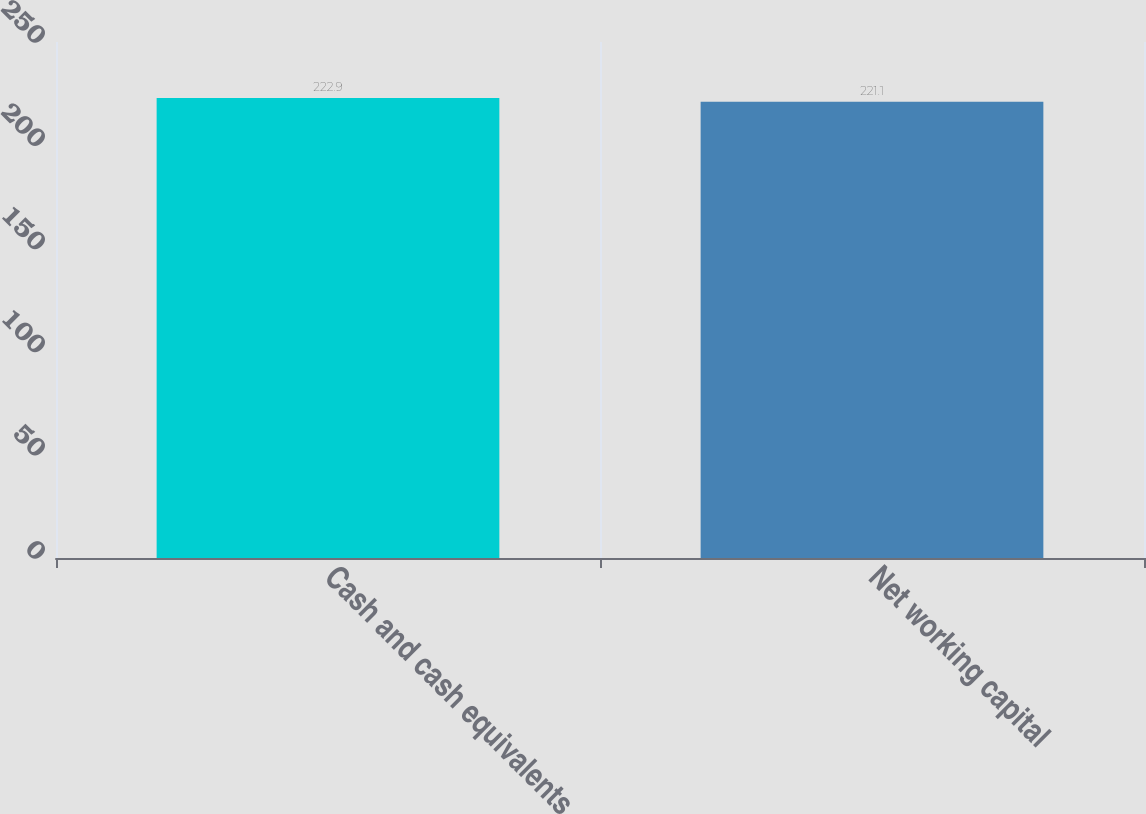Convert chart. <chart><loc_0><loc_0><loc_500><loc_500><bar_chart><fcel>Cash and cash equivalents<fcel>Net working capital<nl><fcel>222.9<fcel>221.1<nl></chart> 